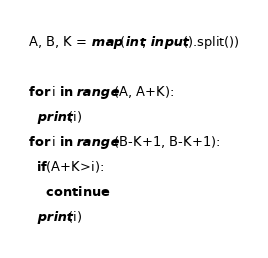Convert code to text. <code><loc_0><loc_0><loc_500><loc_500><_Python_>A, B, K = map(int, input().split())
 
for i in range(A, A+K):
  print(i)
for i in range(B-K+1, B-K+1):
  if(A+K>i):
    continue
  print(i)</code> 